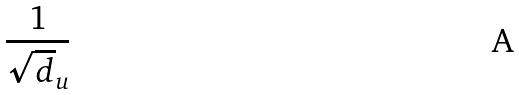Convert formula to latex. <formula><loc_0><loc_0><loc_500><loc_500>\frac { 1 } { \sqrt { d } _ { u } }</formula> 